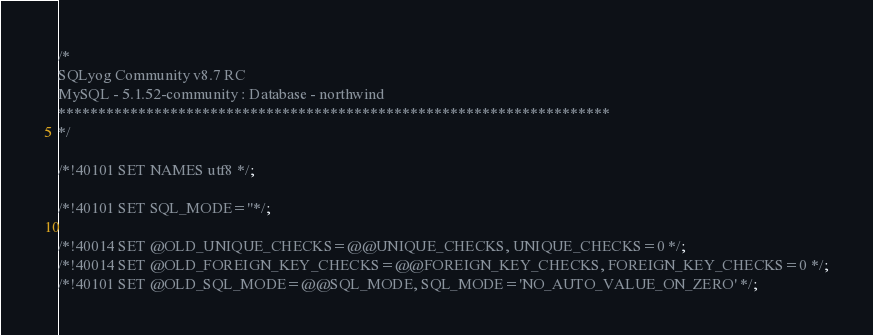Convert code to text. <code><loc_0><loc_0><loc_500><loc_500><_SQL_>/*
SQLyog Community v8.7 RC
MySQL - 5.1.52-community : Database - northwind
*********************************************************************
*/

/*!40101 SET NAMES utf8 */;

/*!40101 SET SQL_MODE=''*/;

/*!40014 SET @OLD_UNIQUE_CHECKS=@@UNIQUE_CHECKS, UNIQUE_CHECKS=0 */;
/*!40014 SET @OLD_FOREIGN_KEY_CHECKS=@@FOREIGN_KEY_CHECKS, FOREIGN_KEY_CHECKS=0 */;
/*!40101 SET @OLD_SQL_MODE=@@SQL_MODE, SQL_MODE='NO_AUTO_VALUE_ON_ZERO' */;</code> 